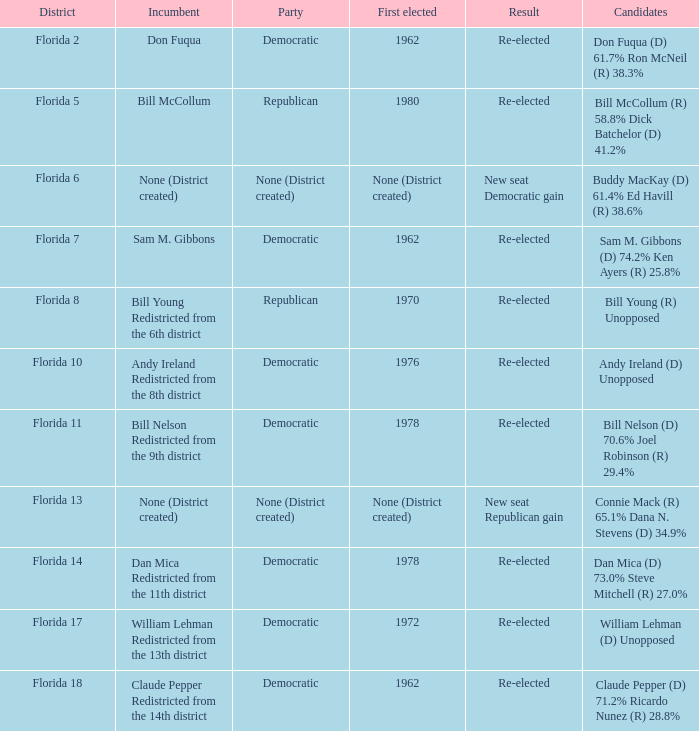 how many candidates with result being new seat democratic gain 1.0. Can you give me this table as a dict? {'header': ['District', 'Incumbent', 'Party', 'First elected', 'Result', 'Candidates'], 'rows': [['Florida 2', 'Don Fuqua', 'Democratic', '1962', 'Re-elected', 'Don Fuqua (D) 61.7% Ron McNeil (R) 38.3%'], ['Florida 5', 'Bill McCollum', 'Republican', '1980', 'Re-elected', 'Bill McCollum (R) 58.8% Dick Batchelor (D) 41.2%'], ['Florida 6', 'None (District created)', 'None (District created)', 'None (District created)', 'New seat Democratic gain', 'Buddy MacKay (D) 61.4% Ed Havill (R) 38.6%'], ['Florida 7', 'Sam M. Gibbons', 'Democratic', '1962', 'Re-elected', 'Sam M. Gibbons (D) 74.2% Ken Ayers (R) 25.8%'], ['Florida 8', 'Bill Young Redistricted from the 6th district', 'Republican', '1970', 'Re-elected', 'Bill Young (R) Unopposed'], ['Florida 10', 'Andy Ireland Redistricted from the 8th district', 'Democratic', '1976', 'Re-elected', 'Andy Ireland (D) Unopposed'], ['Florida 11', 'Bill Nelson Redistricted from the 9th district', 'Democratic', '1978', 'Re-elected', 'Bill Nelson (D) 70.6% Joel Robinson (R) 29.4%'], ['Florida 13', 'None (District created)', 'None (District created)', 'None (District created)', 'New seat Republican gain', 'Connie Mack (R) 65.1% Dana N. Stevens (D) 34.9%'], ['Florida 14', 'Dan Mica Redistricted from the 11th district', 'Democratic', '1978', 'Re-elected', 'Dan Mica (D) 73.0% Steve Mitchell (R) 27.0%'], ['Florida 17', 'William Lehman Redistricted from the 13th district', 'Democratic', '1972', 'Re-elected', 'William Lehman (D) Unopposed'], ['Florida 18', 'Claude Pepper Redistricted from the 14th district', 'Democratic', '1962', 'Re-elected', 'Claude Pepper (D) 71.2% Ricardo Nunez (R) 28.8%']]} 